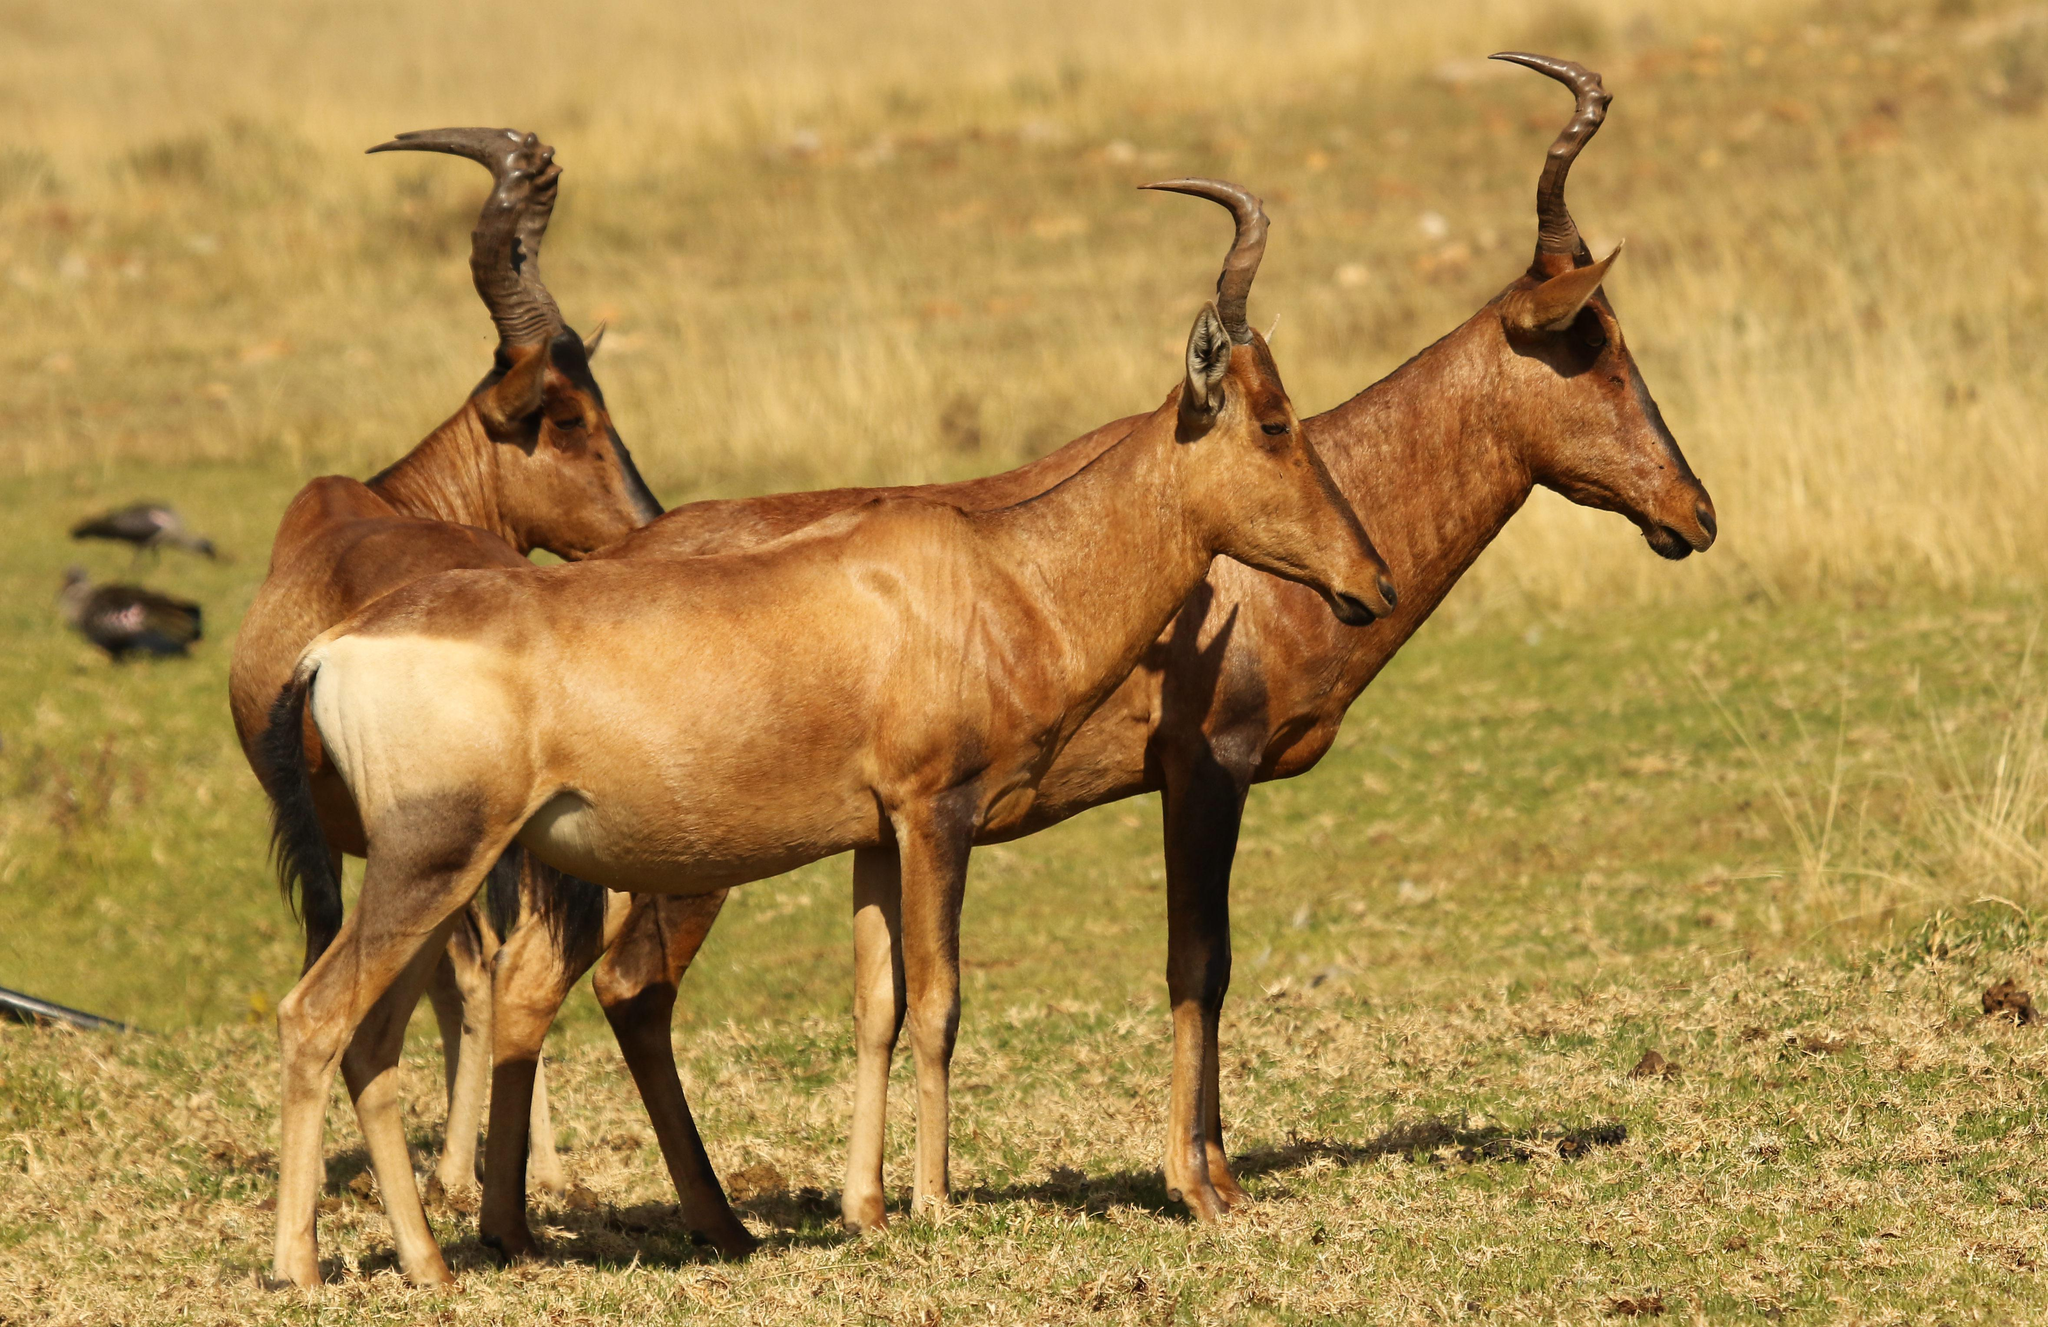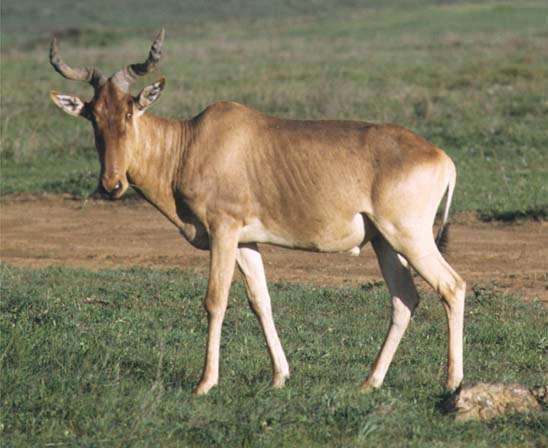The first image is the image on the left, the second image is the image on the right. Given the left and right images, does the statement "Exactly one animal is pointed left." hold true? Answer yes or no. Yes. The first image is the image on the left, the second image is the image on the right. Assess this claim about the two images: "Each image contains only one horned animal, and the animal in the right image stands in profile turned leftward.". Correct or not? Answer yes or no. No. 